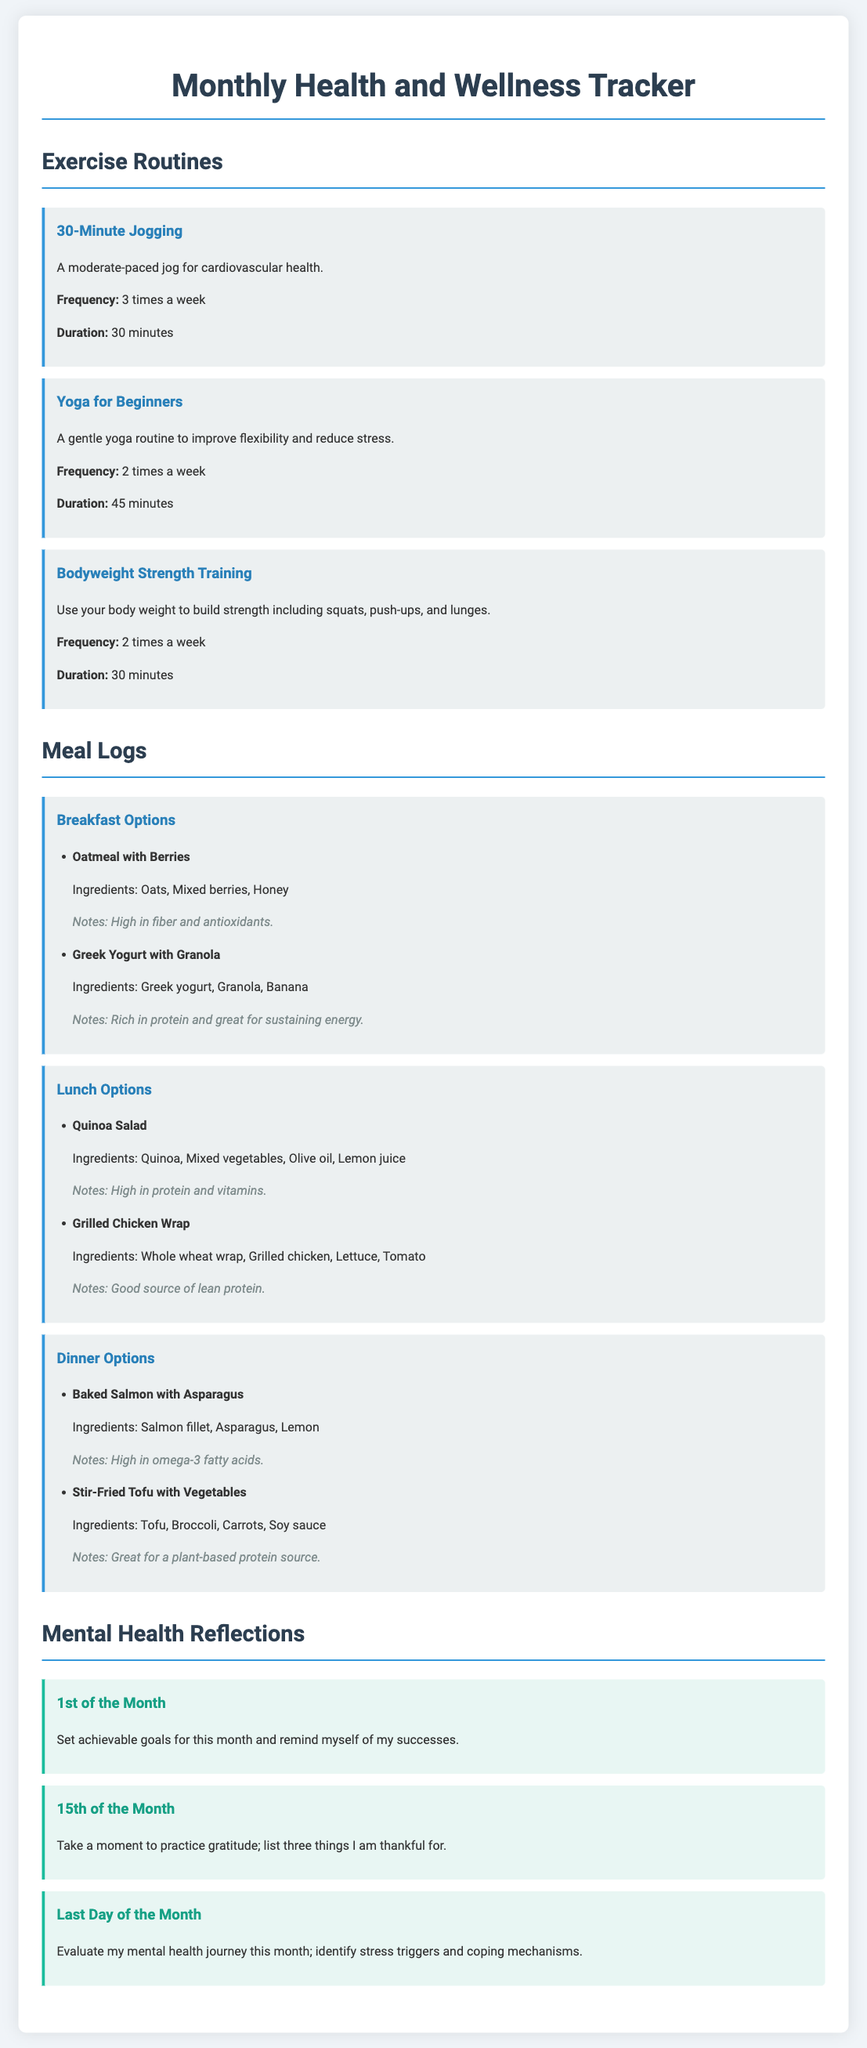What is the title of the document? The title is found in the header of the document, indicating its primary focus.
Answer: Monthly Health and Wellness Tracker How many times a week is the 30-Minute Jogging routine practiced? This information can be found in the description of the exercise routine section.
Answer: 3 times a week What are the ingredients in the Breakfast option "Oatmeal with Berries"? The list of ingredients is provided under the specific meal option, detailing what is included.
Answer: Oats, Mixed berries, Honey What is the mental health reflection for the 15th of the month? This reflection describes a specific activity to focus on mid-month as suggested in the document.
Answer: Take a moment to practice gratitude; list three things I am thankful for How long should the Yoga for Beginners session last? The duration for this exercise can be found in the description of the routine.
Answer: 45 minutes What is the primary benefit of the Baked Salmon with Asparagus dish? The notes provide insight into the health benefits offered by the meal option.
Answer: High in omega-3 fatty acids Which exercise routine is performed twice a week? The document lists exercise routines with their associated frequencies, making this information accessible.
Answer: Yoga for Beginners, Bodyweight Strength Training What kind of salad is mentioned in the lunch options? This question refers to the specific dish listed, which focuses on healthy ingredients.
Answer: Quinoa Salad 